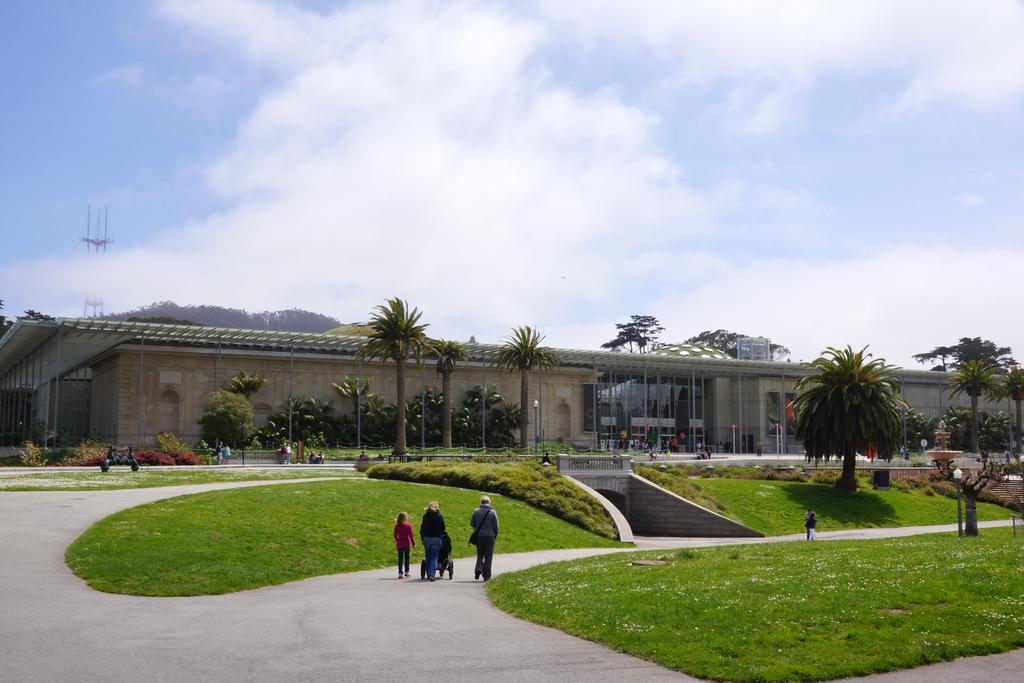What are the people in the image doing? The people in the image are walking on the road. What type of natural environment can be seen in the image? There are grasslands and trees visible in the image. What type of structure can be seen in the image? There is at least one building present in the image. What are the light sources in the image? Light poles are present in the image. What is visible in the background of the image? The sky is visible in the background of the image, and clouds are present in the sky. How many spiders are crawling on the wrist of the person in the image? There are no spiders visible in the image, and no one's wrist is shown. 